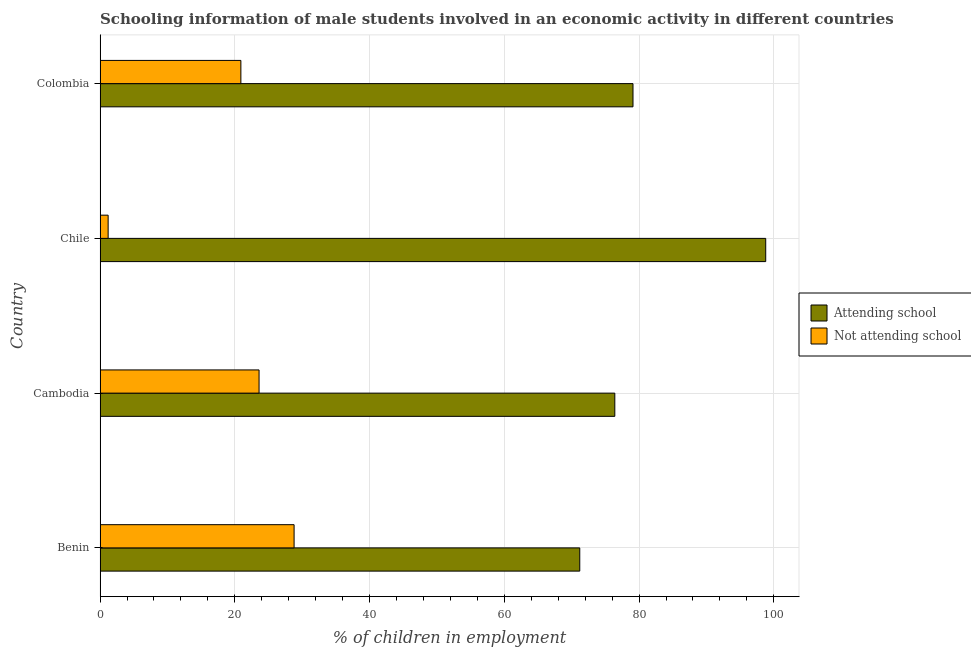How many different coloured bars are there?
Provide a short and direct response. 2. How many groups of bars are there?
Provide a short and direct response. 4. How many bars are there on the 4th tick from the top?
Your response must be concise. 2. What is the label of the 1st group of bars from the top?
Offer a terse response. Colombia. What is the percentage of employed males who are attending school in Cambodia?
Offer a very short reply. 76.4. Across all countries, what is the maximum percentage of employed males who are attending school?
Give a very brief answer. 98.8. In which country was the percentage of employed males who are attending school maximum?
Your answer should be very brief. Chile. In which country was the percentage of employed males who are not attending school minimum?
Provide a short and direct response. Chile. What is the total percentage of employed males who are attending school in the graph?
Ensure brevity in your answer.  325.5. What is the difference between the percentage of employed males who are not attending school in Chile and that in Colombia?
Ensure brevity in your answer.  -19.7. What is the difference between the percentage of employed males who are not attending school in Colombia and the percentage of employed males who are attending school in Cambodia?
Your answer should be very brief. -55.5. What is the average percentage of employed males who are not attending school per country?
Provide a succinct answer. 18.62. What is the difference between the percentage of employed males who are attending school and percentage of employed males who are not attending school in Benin?
Make the answer very short. 42.4. In how many countries, is the percentage of employed males who are attending school greater than 8 %?
Your response must be concise. 4. What is the ratio of the percentage of employed males who are attending school in Benin to that in Cambodia?
Ensure brevity in your answer.  0.93. Is the difference between the percentage of employed males who are not attending school in Benin and Cambodia greater than the difference between the percentage of employed males who are attending school in Benin and Cambodia?
Make the answer very short. Yes. What is the difference between the highest and the second highest percentage of employed males who are not attending school?
Provide a short and direct response. 5.2. What is the difference between the highest and the lowest percentage of employed males who are not attending school?
Make the answer very short. 27.6. In how many countries, is the percentage of employed males who are attending school greater than the average percentage of employed males who are attending school taken over all countries?
Offer a terse response. 1. What does the 2nd bar from the top in Cambodia represents?
Your answer should be very brief. Attending school. What does the 2nd bar from the bottom in Chile represents?
Keep it short and to the point. Not attending school. Are all the bars in the graph horizontal?
Ensure brevity in your answer.  Yes. How many countries are there in the graph?
Your response must be concise. 4. Are the values on the major ticks of X-axis written in scientific E-notation?
Provide a succinct answer. No. Where does the legend appear in the graph?
Offer a very short reply. Center right. How many legend labels are there?
Your response must be concise. 2. What is the title of the graph?
Provide a short and direct response. Schooling information of male students involved in an economic activity in different countries. What is the label or title of the X-axis?
Provide a succinct answer. % of children in employment. What is the % of children in employment of Attending school in Benin?
Your response must be concise. 71.2. What is the % of children in employment in Not attending school in Benin?
Your answer should be compact. 28.8. What is the % of children in employment in Attending school in Cambodia?
Ensure brevity in your answer.  76.4. What is the % of children in employment in Not attending school in Cambodia?
Offer a very short reply. 23.6. What is the % of children in employment in Attending school in Chile?
Provide a succinct answer. 98.8. What is the % of children in employment of Attending school in Colombia?
Provide a succinct answer. 79.1. What is the % of children in employment in Not attending school in Colombia?
Ensure brevity in your answer.  20.9. Across all countries, what is the maximum % of children in employment in Attending school?
Make the answer very short. 98.8. Across all countries, what is the maximum % of children in employment in Not attending school?
Keep it short and to the point. 28.8. Across all countries, what is the minimum % of children in employment of Attending school?
Make the answer very short. 71.2. Across all countries, what is the minimum % of children in employment in Not attending school?
Your answer should be compact. 1.2. What is the total % of children in employment of Attending school in the graph?
Your answer should be very brief. 325.5. What is the total % of children in employment of Not attending school in the graph?
Make the answer very short. 74.5. What is the difference between the % of children in employment of Attending school in Benin and that in Cambodia?
Your answer should be very brief. -5.2. What is the difference between the % of children in employment in Not attending school in Benin and that in Cambodia?
Provide a short and direct response. 5.2. What is the difference between the % of children in employment in Attending school in Benin and that in Chile?
Provide a short and direct response. -27.6. What is the difference between the % of children in employment in Not attending school in Benin and that in Chile?
Offer a very short reply. 27.6. What is the difference between the % of children in employment of Attending school in Benin and that in Colombia?
Provide a succinct answer. -7.9. What is the difference between the % of children in employment of Not attending school in Benin and that in Colombia?
Ensure brevity in your answer.  7.9. What is the difference between the % of children in employment of Attending school in Cambodia and that in Chile?
Your answer should be very brief. -22.4. What is the difference between the % of children in employment of Not attending school in Cambodia and that in Chile?
Your answer should be compact. 22.4. What is the difference between the % of children in employment of Not attending school in Cambodia and that in Colombia?
Make the answer very short. 2.7. What is the difference between the % of children in employment in Not attending school in Chile and that in Colombia?
Ensure brevity in your answer.  -19.7. What is the difference between the % of children in employment of Attending school in Benin and the % of children in employment of Not attending school in Cambodia?
Make the answer very short. 47.6. What is the difference between the % of children in employment in Attending school in Benin and the % of children in employment in Not attending school in Chile?
Your answer should be compact. 70. What is the difference between the % of children in employment in Attending school in Benin and the % of children in employment in Not attending school in Colombia?
Give a very brief answer. 50.3. What is the difference between the % of children in employment of Attending school in Cambodia and the % of children in employment of Not attending school in Chile?
Offer a terse response. 75.2. What is the difference between the % of children in employment in Attending school in Cambodia and the % of children in employment in Not attending school in Colombia?
Keep it short and to the point. 55.5. What is the difference between the % of children in employment of Attending school in Chile and the % of children in employment of Not attending school in Colombia?
Your answer should be very brief. 77.9. What is the average % of children in employment in Attending school per country?
Provide a succinct answer. 81.38. What is the average % of children in employment in Not attending school per country?
Offer a very short reply. 18.62. What is the difference between the % of children in employment of Attending school and % of children in employment of Not attending school in Benin?
Make the answer very short. 42.4. What is the difference between the % of children in employment in Attending school and % of children in employment in Not attending school in Cambodia?
Provide a short and direct response. 52.8. What is the difference between the % of children in employment of Attending school and % of children in employment of Not attending school in Chile?
Offer a terse response. 97.6. What is the difference between the % of children in employment of Attending school and % of children in employment of Not attending school in Colombia?
Your response must be concise. 58.2. What is the ratio of the % of children in employment of Attending school in Benin to that in Cambodia?
Give a very brief answer. 0.93. What is the ratio of the % of children in employment of Not attending school in Benin to that in Cambodia?
Provide a succinct answer. 1.22. What is the ratio of the % of children in employment of Attending school in Benin to that in Chile?
Keep it short and to the point. 0.72. What is the ratio of the % of children in employment of Attending school in Benin to that in Colombia?
Your answer should be very brief. 0.9. What is the ratio of the % of children in employment of Not attending school in Benin to that in Colombia?
Your answer should be compact. 1.38. What is the ratio of the % of children in employment in Attending school in Cambodia to that in Chile?
Your response must be concise. 0.77. What is the ratio of the % of children in employment of Not attending school in Cambodia to that in Chile?
Your answer should be very brief. 19.67. What is the ratio of the % of children in employment in Attending school in Cambodia to that in Colombia?
Keep it short and to the point. 0.97. What is the ratio of the % of children in employment in Not attending school in Cambodia to that in Colombia?
Keep it short and to the point. 1.13. What is the ratio of the % of children in employment in Attending school in Chile to that in Colombia?
Provide a short and direct response. 1.25. What is the ratio of the % of children in employment of Not attending school in Chile to that in Colombia?
Offer a very short reply. 0.06. What is the difference between the highest and the second highest % of children in employment of Not attending school?
Provide a succinct answer. 5.2. What is the difference between the highest and the lowest % of children in employment in Attending school?
Offer a very short reply. 27.6. What is the difference between the highest and the lowest % of children in employment in Not attending school?
Offer a terse response. 27.6. 